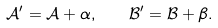Convert formula to latex. <formula><loc_0><loc_0><loc_500><loc_500>\mathcal { A } ^ { \prime } = \mathcal { A } + \alpha , \quad \mathcal { B } ^ { \prime } = \mathcal { B } + \beta .</formula> 